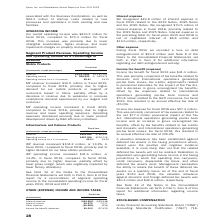From Qorvo's financial document, What are the respective revenue in 2018 and 2019? The document shows two values: $788,495 and $892,665 (in thousands). From the document: "Revenue $892,665 $788,495 Operating income $267,304 $235,719 Operating income as a % of revenue 29.9% 29.9% Revenue $892,665 $788,495 Operating income..." Also, What are the respective operating income in 2018 and 2019? The document shows two values: $235,719 and $267,304 (in thousands). From the document: "Revenue $892,665 $788,495 Operating income $267,304 $235,719 Operating income as a % of revenue 29.9% 29.9% evenue $892,665 $788,495 Operating income ..." Also, What are the respective operating income as a % of revenue in 2018 and 2019? The document shows two values: 29.9% and 29.9%. From the document: "67,304 $235,719 Operating income as a % of revenue 29.9% 29.9%..." Also, can you calculate: What is the total revenue in 2018 and 2019? Based on the calculation: ($788,495 + $892,665) , the result is 1681160 (in thousands). This is based on the information: "Revenue $892,665 $788,495 Operating income $267,304 $235,719 Operating income as a % of revenue 29.9% 29.9% Revenue $892,665 $788,495 Operating income $267,304 $235,719 Operating income as a % of reve..." The key data points involved are: 788,495, 892,665. Also, can you calculate: What is the value of the revenue in 2018 as a percentage of the revenue in 2019? Based on the calculation: ($788,495/$892,665) , the result is 88.33 (percentage). This is based on the information: "Revenue $892,665 $788,495 Operating income $267,304 $235,719 Operating income as a % of revenue 29.9% 29.9% Revenue $892,665 $788,495 Operating income $267,304 $235,719 Operating income as a % of reve..." The key data points involved are: 788,495, 892,665. Also, can you calculate: What is the percentage change in the 2018 and 2019 revenue? To answer this question, I need to perform calculations using the financial data. The calculation is: (892,665 - 788,495)/788,495 , which equals 13.21 (percentage). This is based on the information: "Revenue $892,665 $788,495 Operating income $267,304 $235,719 Operating income as a % of revenue 29.9% 29.9% Revenue $892,665 $788,495 Operating income $267,304 $235,719 Operating income as a % of reve..." The key data points involved are: 788,495, 892,665. 